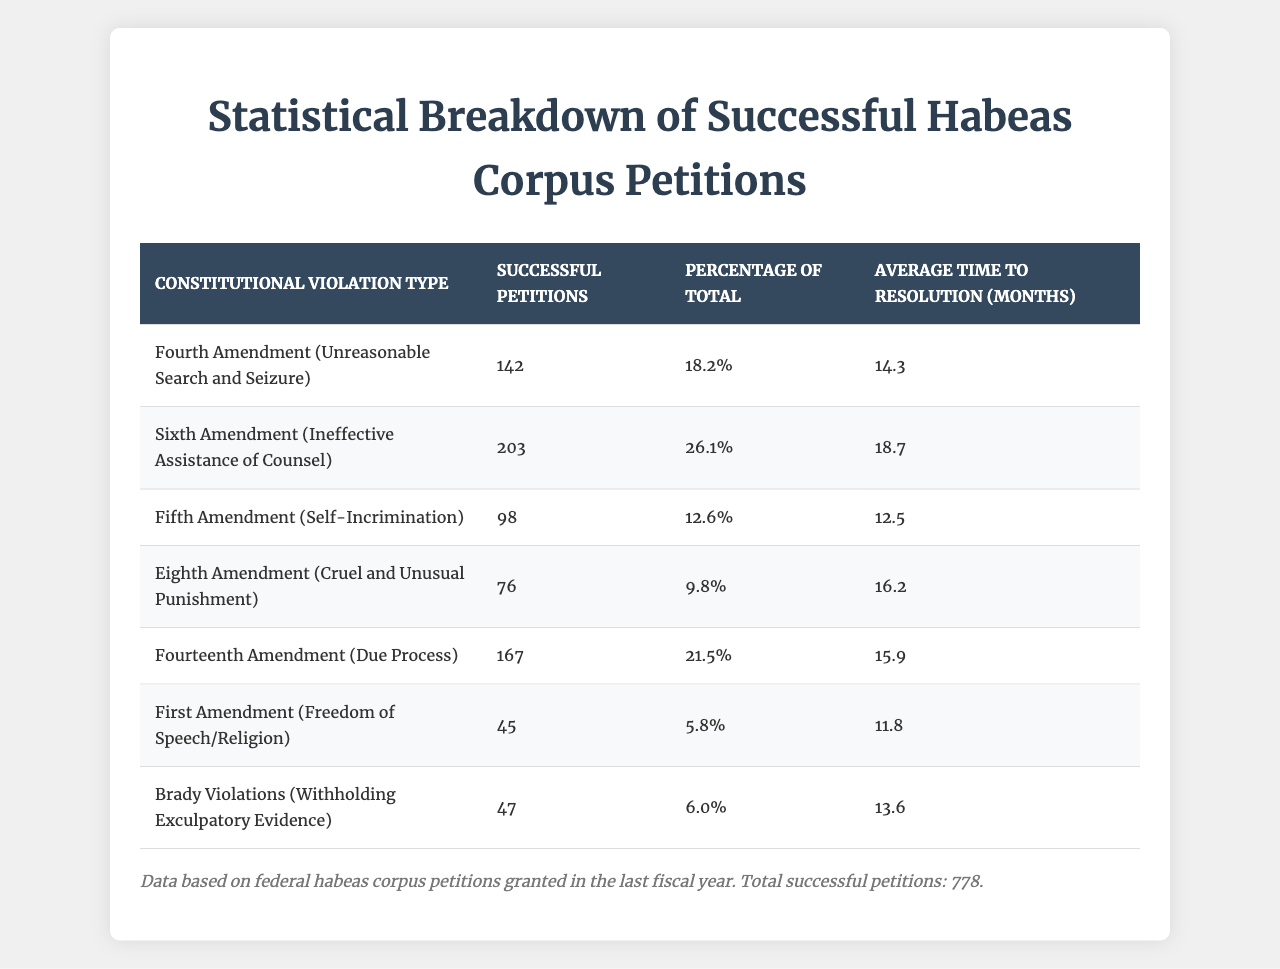What is the total number of successful habeas corpus petitions recorded? From the footnote, it is stated that the total number of successful petitions is 778.
Answer: 778 Which constitutional violation type had the highest number of successful petitions? By reviewing the "Successful Petitions" column, the "Sixth Amendment (Ineffective Assistance of Counsel)" has the highest number at 203.
Answer: Sixth Amendment (Ineffective Assistance of Counsel) What percentage of the total successful petitions did the Fourth Amendment violations account for? Looking at the "Percentage of Total" column for the "Fourth Amendment (Unreasonable Search and Seizure)", it shows 18.2%.
Answer: 18.2% What is the average time to resolution for cases based on the Eighth Amendment? The table indicates that the average time to resolution for "Eighth Amendment (Cruel and Unusual Punishment)" is 16.2 months.
Answer: 16.2 months How many successful petitions are related to violations of the First Amendment? Referring to the table, the number of successful petitions for the "First Amendment (Freedom of Speech/Religion)" is 45.
Answer: 45 What is the average time to resolution across all types of constitutional violations listed? To find the overall average time to resolution, sum the average times for all violations (14.3 + 18.7 + 12.5 + 16.2 + 15.9 + 11.8 + 13.6 = 102). Then divide by the number of types (7): 102 / 7 ≈ 14.57 months.
Answer: 14.57 months Is the percentage of successful habeas corpus petitions for the Fourteenth Amendment lower than that of the Sixth Amendment? The "Fourteenth Amendment (Due Process)" has a percentage of 21.5% while the "Sixth Amendment (Ineffective Assistance of Counsel)" has 26.1%. Since 21.5% is less than 26.1%, the statement is true.
Answer: Yes What is the difference in successful petitions between the Fifth and the Eighth Amendments? The "Fifth Amendment (Self-Incrimination)" has 98 successful petitions, while the "Eighth Amendment (Cruel and Unusual Punishment)" has 76. The difference is 98 - 76 = 22 successful petitions.
Answer: 22 Considering the data, which constitutional violation type had the lowest percentage of successful petitions and what was that percentage? In reviewing the "Percentage of Total" column, the "First Amendment (Freedom of Speech/Religion)" has the lowest percentage at 5.8%.
Answer: First Amendment (5.8%) If we were to group violations by their average time to resolution, which group would the Sixth Amendment fall into? The average time of the "Sixth Amendment (Ineffective Assistance of Counsel)" is 18.7 months. Comparatively, this is higher than other types like the First or Fifth Amendments but lower than the Eighth. Hence, it falls into the above-average group.
Answer: Above average group Which types of constitutional violations account for more than 20% of successful petitions combined? Adding the percentages of the "Sixth" (26.1%) and the "Fourteenth" (21.5%), their combined total is 47.6%, which exceeds 20%.
Answer: Sixth and Fourteenth Amendments 